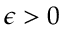Convert formula to latex. <formula><loc_0><loc_0><loc_500><loc_500>\epsilon > 0</formula> 